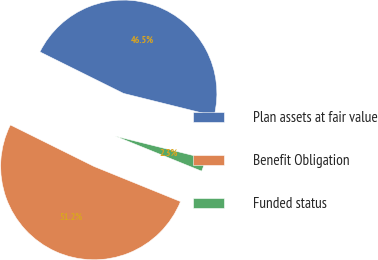Convert chart to OTSL. <chart><loc_0><loc_0><loc_500><loc_500><pie_chart><fcel>Plan assets at fair value<fcel>Benefit Obligation<fcel>Funded status<nl><fcel>46.54%<fcel>51.19%<fcel>2.26%<nl></chart> 